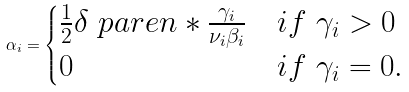Convert formula to latex. <formula><loc_0><loc_0><loc_500><loc_500>\alpha _ { i } = \begin{cases} \frac { 1 } { 2 } \delta \ p a r e n * { \frac { \gamma _ { i } } { \nu _ { i } \beta _ { i } } } & i f \ \gamma _ { i } > 0 \\ 0 & i f \ \gamma _ { i } = 0 . \end{cases}</formula> 